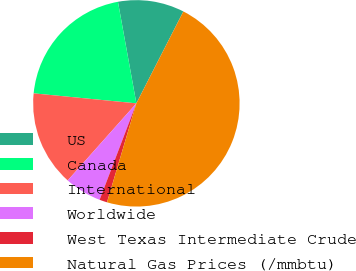Convert chart to OTSL. <chart><loc_0><loc_0><loc_500><loc_500><pie_chart><fcel>US<fcel>Canada<fcel>International<fcel>Worldwide<fcel>West Texas Intermediate Crude<fcel>Natural Gas Prices (/mmbtu)<nl><fcel>10.38%<fcel>20.6%<fcel>14.96%<fcel>5.79%<fcel>1.2%<fcel>47.07%<nl></chart> 